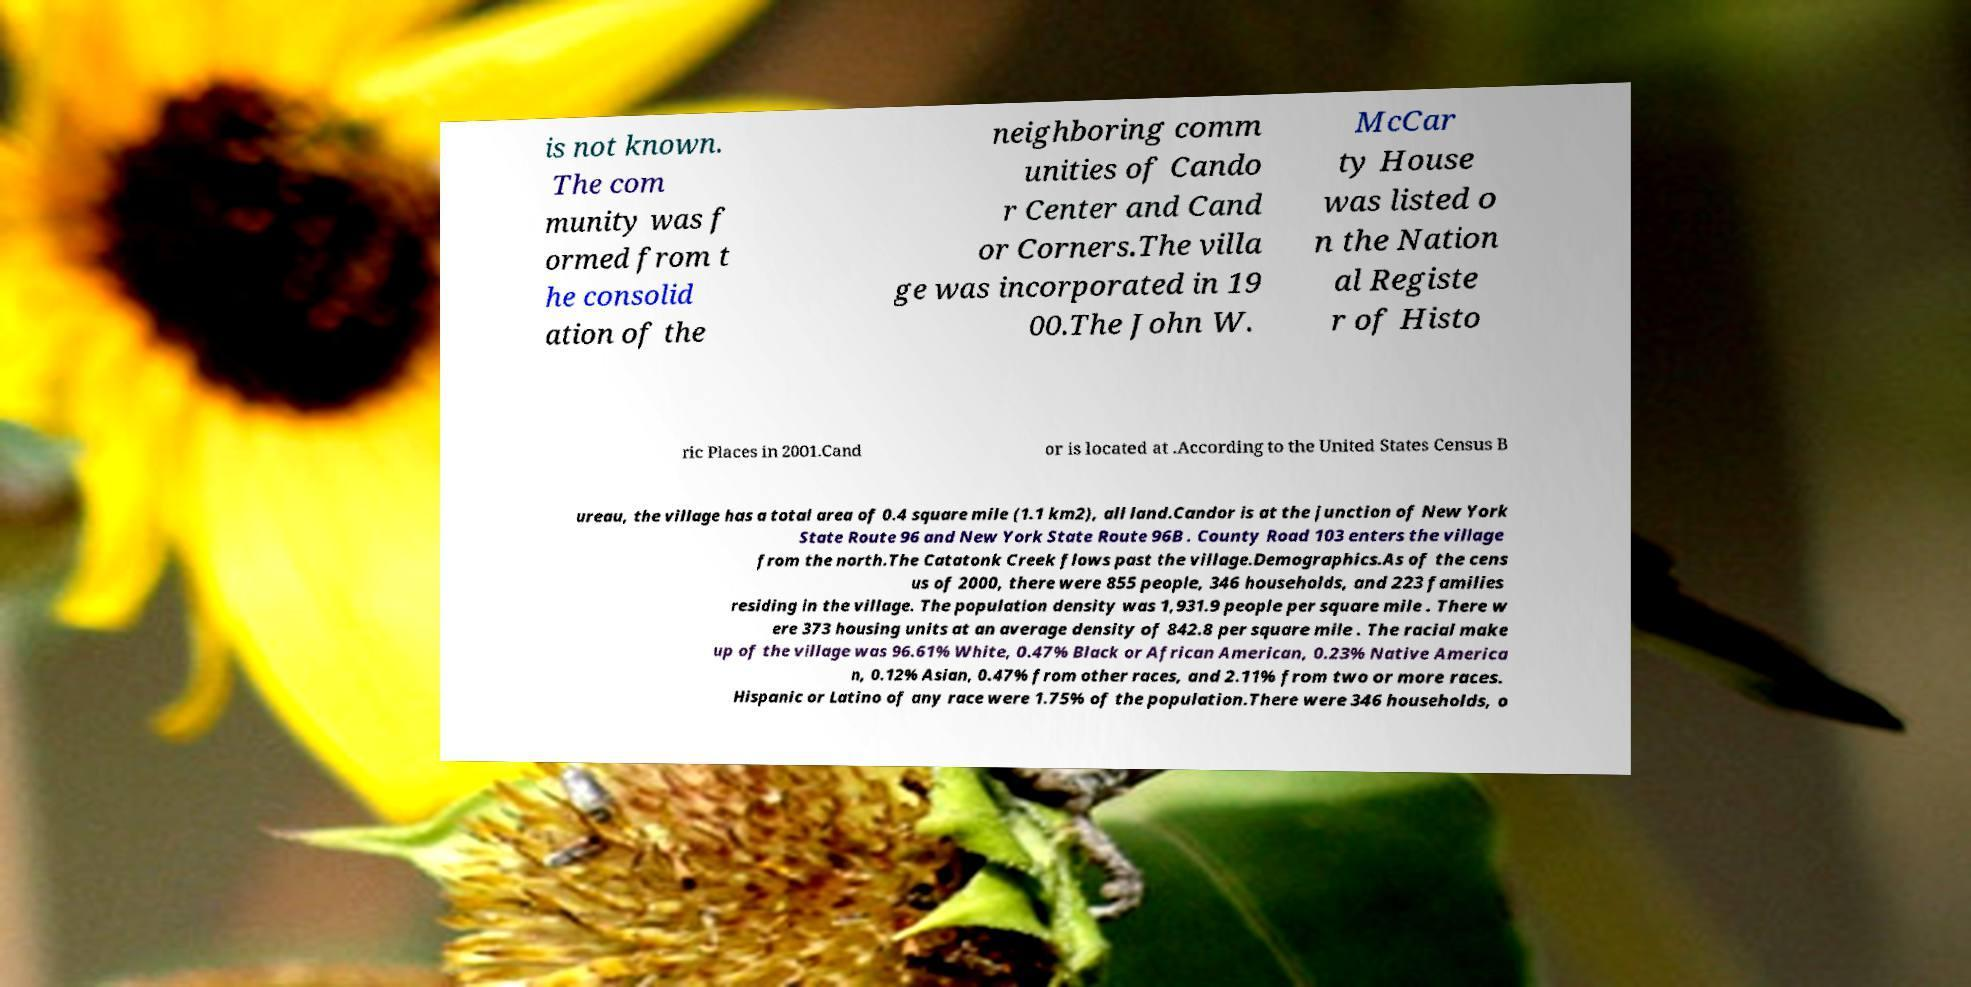Could you extract and type out the text from this image? is not known. The com munity was f ormed from t he consolid ation of the neighboring comm unities of Cando r Center and Cand or Corners.The villa ge was incorporated in 19 00.The John W. McCar ty House was listed o n the Nation al Registe r of Histo ric Places in 2001.Cand or is located at .According to the United States Census B ureau, the village has a total area of 0.4 square mile (1.1 km2), all land.Candor is at the junction of New York State Route 96 and New York State Route 96B . County Road 103 enters the village from the north.The Catatonk Creek flows past the village.Demographics.As of the cens us of 2000, there were 855 people, 346 households, and 223 families residing in the village. The population density was 1,931.9 people per square mile . There w ere 373 housing units at an average density of 842.8 per square mile . The racial make up of the village was 96.61% White, 0.47% Black or African American, 0.23% Native America n, 0.12% Asian, 0.47% from other races, and 2.11% from two or more races. Hispanic or Latino of any race were 1.75% of the population.There were 346 households, o 